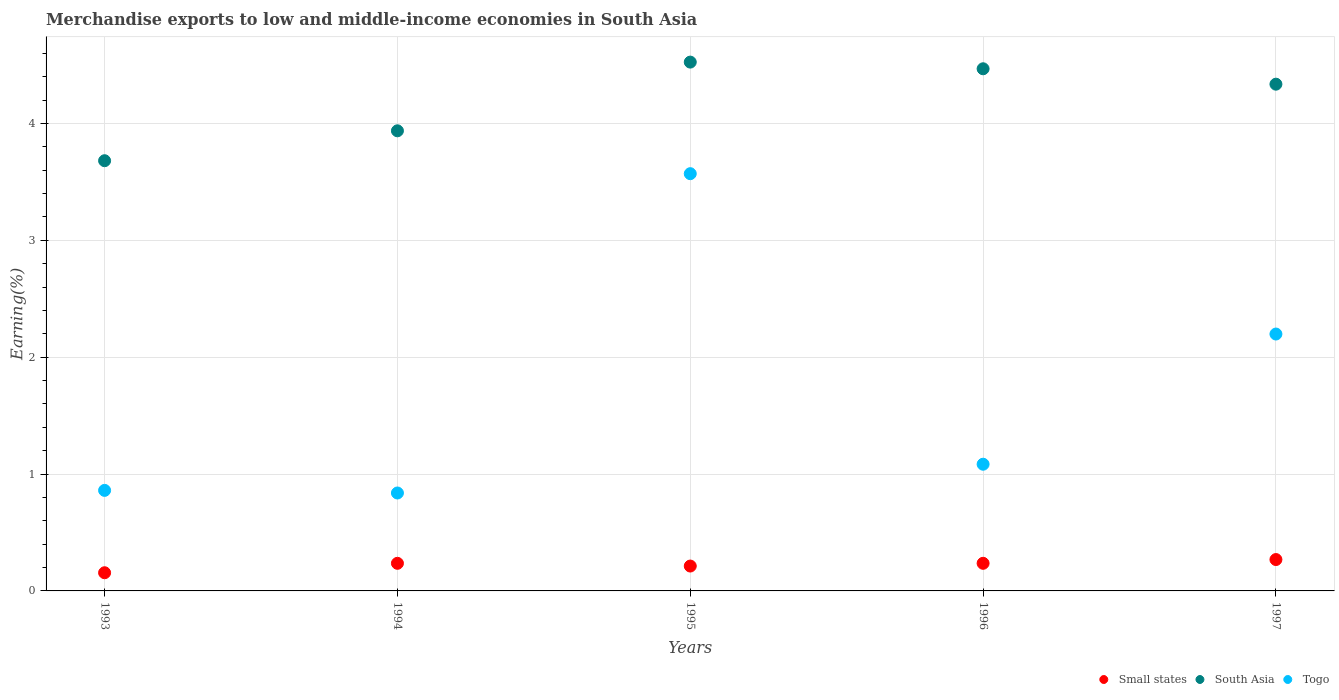Is the number of dotlines equal to the number of legend labels?
Offer a terse response. Yes. What is the percentage of amount earned from merchandise exports in South Asia in 1997?
Your answer should be compact. 4.34. Across all years, what is the maximum percentage of amount earned from merchandise exports in Small states?
Provide a succinct answer. 0.27. Across all years, what is the minimum percentage of amount earned from merchandise exports in Togo?
Offer a very short reply. 0.84. In which year was the percentage of amount earned from merchandise exports in South Asia maximum?
Provide a succinct answer. 1995. What is the total percentage of amount earned from merchandise exports in South Asia in the graph?
Your answer should be compact. 20.95. What is the difference between the percentage of amount earned from merchandise exports in Togo in 1993 and that in 1997?
Make the answer very short. -1.34. What is the difference between the percentage of amount earned from merchandise exports in Small states in 1993 and the percentage of amount earned from merchandise exports in South Asia in 1997?
Give a very brief answer. -4.18. What is the average percentage of amount earned from merchandise exports in South Asia per year?
Your answer should be compact. 4.19. In the year 1997, what is the difference between the percentage of amount earned from merchandise exports in Small states and percentage of amount earned from merchandise exports in South Asia?
Your answer should be very brief. -4.07. What is the ratio of the percentage of amount earned from merchandise exports in Togo in 1994 to that in 1995?
Offer a very short reply. 0.23. Is the percentage of amount earned from merchandise exports in Small states in 1995 less than that in 1997?
Your response must be concise. Yes. What is the difference between the highest and the second highest percentage of amount earned from merchandise exports in Togo?
Offer a very short reply. 1.37. What is the difference between the highest and the lowest percentage of amount earned from merchandise exports in Small states?
Your answer should be very brief. 0.11. Is the sum of the percentage of amount earned from merchandise exports in Togo in 1994 and 1997 greater than the maximum percentage of amount earned from merchandise exports in Small states across all years?
Provide a short and direct response. Yes. Is the percentage of amount earned from merchandise exports in Small states strictly less than the percentage of amount earned from merchandise exports in South Asia over the years?
Offer a very short reply. Yes. How many dotlines are there?
Offer a very short reply. 3. How many years are there in the graph?
Your response must be concise. 5. Are the values on the major ticks of Y-axis written in scientific E-notation?
Provide a succinct answer. No. Does the graph contain any zero values?
Ensure brevity in your answer.  No. Does the graph contain grids?
Provide a short and direct response. Yes. Where does the legend appear in the graph?
Provide a short and direct response. Bottom right. How are the legend labels stacked?
Your answer should be compact. Horizontal. What is the title of the graph?
Provide a short and direct response. Merchandise exports to low and middle-income economies in South Asia. Does "Sub-Saharan Africa (all income levels)" appear as one of the legend labels in the graph?
Provide a short and direct response. No. What is the label or title of the Y-axis?
Ensure brevity in your answer.  Earning(%). What is the Earning(%) of Small states in 1993?
Offer a terse response. 0.16. What is the Earning(%) of South Asia in 1993?
Provide a succinct answer. 3.68. What is the Earning(%) in Togo in 1993?
Provide a succinct answer. 0.86. What is the Earning(%) of Small states in 1994?
Provide a succinct answer. 0.24. What is the Earning(%) of South Asia in 1994?
Keep it short and to the point. 3.94. What is the Earning(%) of Togo in 1994?
Give a very brief answer. 0.84. What is the Earning(%) in Small states in 1995?
Your answer should be very brief. 0.21. What is the Earning(%) of South Asia in 1995?
Your response must be concise. 4.52. What is the Earning(%) of Togo in 1995?
Offer a very short reply. 3.57. What is the Earning(%) of Small states in 1996?
Your answer should be compact. 0.24. What is the Earning(%) in South Asia in 1996?
Offer a very short reply. 4.47. What is the Earning(%) of Togo in 1996?
Provide a succinct answer. 1.08. What is the Earning(%) in Small states in 1997?
Provide a short and direct response. 0.27. What is the Earning(%) of South Asia in 1997?
Ensure brevity in your answer.  4.34. What is the Earning(%) of Togo in 1997?
Ensure brevity in your answer.  2.2. Across all years, what is the maximum Earning(%) of Small states?
Provide a succinct answer. 0.27. Across all years, what is the maximum Earning(%) of South Asia?
Offer a terse response. 4.52. Across all years, what is the maximum Earning(%) of Togo?
Your answer should be very brief. 3.57. Across all years, what is the minimum Earning(%) of Small states?
Your response must be concise. 0.16. Across all years, what is the minimum Earning(%) of South Asia?
Offer a very short reply. 3.68. Across all years, what is the minimum Earning(%) of Togo?
Provide a short and direct response. 0.84. What is the total Earning(%) of Small states in the graph?
Make the answer very short. 1.11. What is the total Earning(%) of South Asia in the graph?
Your answer should be compact. 20.95. What is the total Earning(%) of Togo in the graph?
Give a very brief answer. 8.55. What is the difference between the Earning(%) of Small states in 1993 and that in 1994?
Your answer should be very brief. -0.08. What is the difference between the Earning(%) in South Asia in 1993 and that in 1994?
Keep it short and to the point. -0.26. What is the difference between the Earning(%) of Togo in 1993 and that in 1994?
Your response must be concise. 0.02. What is the difference between the Earning(%) of Small states in 1993 and that in 1995?
Your answer should be compact. -0.06. What is the difference between the Earning(%) in South Asia in 1993 and that in 1995?
Provide a succinct answer. -0.84. What is the difference between the Earning(%) in Togo in 1993 and that in 1995?
Give a very brief answer. -2.71. What is the difference between the Earning(%) of Small states in 1993 and that in 1996?
Provide a succinct answer. -0.08. What is the difference between the Earning(%) in South Asia in 1993 and that in 1996?
Your answer should be compact. -0.79. What is the difference between the Earning(%) in Togo in 1993 and that in 1996?
Give a very brief answer. -0.22. What is the difference between the Earning(%) of Small states in 1993 and that in 1997?
Provide a succinct answer. -0.11. What is the difference between the Earning(%) of South Asia in 1993 and that in 1997?
Make the answer very short. -0.65. What is the difference between the Earning(%) in Togo in 1993 and that in 1997?
Ensure brevity in your answer.  -1.34. What is the difference between the Earning(%) of Small states in 1994 and that in 1995?
Your answer should be very brief. 0.02. What is the difference between the Earning(%) of South Asia in 1994 and that in 1995?
Ensure brevity in your answer.  -0.59. What is the difference between the Earning(%) in Togo in 1994 and that in 1995?
Make the answer very short. -2.73. What is the difference between the Earning(%) of South Asia in 1994 and that in 1996?
Offer a very short reply. -0.53. What is the difference between the Earning(%) in Togo in 1994 and that in 1996?
Your answer should be compact. -0.25. What is the difference between the Earning(%) in Small states in 1994 and that in 1997?
Ensure brevity in your answer.  -0.03. What is the difference between the Earning(%) of South Asia in 1994 and that in 1997?
Your answer should be very brief. -0.4. What is the difference between the Earning(%) of Togo in 1994 and that in 1997?
Make the answer very short. -1.36. What is the difference between the Earning(%) of Small states in 1995 and that in 1996?
Offer a terse response. -0.02. What is the difference between the Earning(%) in South Asia in 1995 and that in 1996?
Your answer should be compact. 0.06. What is the difference between the Earning(%) of Togo in 1995 and that in 1996?
Give a very brief answer. 2.49. What is the difference between the Earning(%) in Small states in 1995 and that in 1997?
Give a very brief answer. -0.06. What is the difference between the Earning(%) of South Asia in 1995 and that in 1997?
Your response must be concise. 0.19. What is the difference between the Earning(%) of Togo in 1995 and that in 1997?
Your response must be concise. 1.37. What is the difference between the Earning(%) in Small states in 1996 and that in 1997?
Provide a short and direct response. -0.03. What is the difference between the Earning(%) in South Asia in 1996 and that in 1997?
Give a very brief answer. 0.13. What is the difference between the Earning(%) of Togo in 1996 and that in 1997?
Offer a very short reply. -1.11. What is the difference between the Earning(%) of Small states in 1993 and the Earning(%) of South Asia in 1994?
Ensure brevity in your answer.  -3.78. What is the difference between the Earning(%) in Small states in 1993 and the Earning(%) in Togo in 1994?
Your answer should be compact. -0.68. What is the difference between the Earning(%) of South Asia in 1993 and the Earning(%) of Togo in 1994?
Ensure brevity in your answer.  2.84. What is the difference between the Earning(%) in Small states in 1993 and the Earning(%) in South Asia in 1995?
Offer a terse response. -4.37. What is the difference between the Earning(%) of Small states in 1993 and the Earning(%) of Togo in 1995?
Make the answer very short. -3.41. What is the difference between the Earning(%) of South Asia in 1993 and the Earning(%) of Togo in 1995?
Give a very brief answer. 0.11. What is the difference between the Earning(%) of Small states in 1993 and the Earning(%) of South Asia in 1996?
Your answer should be compact. -4.31. What is the difference between the Earning(%) of Small states in 1993 and the Earning(%) of Togo in 1996?
Offer a very short reply. -0.93. What is the difference between the Earning(%) in South Asia in 1993 and the Earning(%) in Togo in 1996?
Ensure brevity in your answer.  2.6. What is the difference between the Earning(%) of Small states in 1993 and the Earning(%) of South Asia in 1997?
Make the answer very short. -4.18. What is the difference between the Earning(%) of Small states in 1993 and the Earning(%) of Togo in 1997?
Your response must be concise. -2.04. What is the difference between the Earning(%) in South Asia in 1993 and the Earning(%) in Togo in 1997?
Your answer should be compact. 1.48. What is the difference between the Earning(%) in Small states in 1994 and the Earning(%) in South Asia in 1995?
Offer a very short reply. -4.29. What is the difference between the Earning(%) in Small states in 1994 and the Earning(%) in Togo in 1995?
Your answer should be compact. -3.33. What is the difference between the Earning(%) in South Asia in 1994 and the Earning(%) in Togo in 1995?
Offer a very short reply. 0.37. What is the difference between the Earning(%) of Small states in 1994 and the Earning(%) of South Asia in 1996?
Offer a terse response. -4.23. What is the difference between the Earning(%) in Small states in 1994 and the Earning(%) in Togo in 1996?
Your answer should be compact. -0.85. What is the difference between the Earning(%) of South Asia in 1994 and the Earning(%) of Togo in 1996?
Your answer should be compact. 2.85. What is the difference between the Earning(%) of Small states in 1994 and the Earning(%) of South Asia in 1997?
Make the answer very short. -4.1. What is the difference between the Earning(%) in Small states in 1994 and the Earning(%) in Togo in 1997?
Give a very brief answer. -1.96. What is the difference between the Earning(%) in South Asia in 1994 and the Earning(%) in Togo in 1997?
Keep it short and to the point. 1.74. What is the difference between the Earning(%) of Small states in 1995 and the Earning(%) of South Asia in 1996?
Make the answer very short. -4.26. What is the difference between the Earning(%) of Small states in 1995 and the Earning(%) of Togo in 1996?
Give a very brief answer. -0.87. What is the difference between the Earning(%) in South Asia in 1995 and the Earning(%) in Togo in 1996?
Keep it short and to the point. 3.44. What is the difference between the Earning(%) in Small states in 1995 and the Earning(%) in South Asia in 1997?
Ensure brevity in your answer.  -4.12. What is the difference between the Earning(%) in Small states in 1995 and the Earning(%) in Togo in 1997?
Offer a terse response. -1.99. What is the difference between the Earning(%) in South Asia in 1995 and the Earning(%) in Togo in 1997?
Offer a very short reply. 2.33. What is the difference between the Earning(%) of Small states in 1996 and the Earning(%) of South Asia in 1997?
Provide a succinct answer. -4.1. What is the difference between the Earning(%) of Small states in 1996 and the Earning(%) of Togo in 1997?
Keep it short and to the point. -1.96. What is the difference between the Earning(%) in South Asia in 1996 and the Earning(%) in Togo in 1997?
Offer a very short reply. 2.27. What is the average Earning(%) of Small states per year?
Your response must be concise. 0.22. What is the average Earning(%) of South Asia per year?
Keep it short and to the point. 4.19. What is the average Earning(%) of Togo per year?
Make the answer very short. 1.71. In the year 1993, what is the difference between the Earning(%) of Small states and Earning(%) of South Asia?
Provide a succinct answer. -3.53. In the year 1993, what is the difference between the Earning(%) of Small states and Earning(%) of Togo?
Give a very brief answer. -0.7. In the year 1993, what is the difference between the Earning(%) of South Asia and Earning(%) of Togo?
Make the answer very short. 2.82. In the year 1994, what is the difference between the Earning(%) in Small states and Earning(%) in South Asia?
Your answer should be very brief. -3.7. In the year 1994, what is the difference between the Earning(%) in Small states and Earning(%) in Togo?
Provide a short and direct response. -0.6. In the year 1994, what is the difference between the Earning(%) in South Asia and Earning(%) in Togo?
Provide a short and direct response. 3.1. In the year 1995, what is the difference between the Earning(%) of Small states and Earning(%) of South Asia?
Keep it short and to the point. -4.31. In the year 1995, what is the difference between the Earning(%) in Small states and Earning(%) in Togo?
Provide a short and direct response. -3.36. In the year 1995, what is the difference between the Earning(%) in South Asia and Earning(%) in Togo?
Offer a terse response. 0.95. In the year 1996, what is the difference between the Earning(%) in Small states and Earning(%) in South Asia?
Your answer should be compact. -4.23. In the year 1996, what is the difference between the Earning(%) of Small states and Earning(%) of Togo?
Provide a short and direct response. -0.85. In the year 1996, what is the difference between the Earning(%) in South Asia and Earning(%) in Togo?
Provide a succinct answer. 3.38. In the year 1997, what is the difference between the Earning(%) of Small states and Earning(%) of South Asia?
Provide a succinct answer. -4.07. In the year 1997, what is the difference between the Earning(%) in Small states and Earning(%) in Togo?
Ensure brevity in your answer.  -1.93. In the year 1997, what is the difference between the Earning(%) in South Asia and Earning(%) in Togo?
Provide a short and direct response. 2.14. What is the ratio of the Earning(%) in Small states in 1993 to that in 1994?
Offer a very short reply. 0.66. What is the ratio of the Earning(%) of South Asia in 1993 to that in 1994?
Give a very brief answer. 0.94. What is the ratio of the Earning(%) of Togo in 1993 to that in 1994?
Provide a short and direct response. 1.03. What is the ratio of the Earning(%) in Small states in 1993 to that in 1995?
Offer a very short reply. 0.73. What is the ratio of the Earning(%) of South Asia in 1993 to that in 1995?
Make the answer very short. 0.81. What is the ratio of the Earning(%) in Togo in 1993 to that in 1995?
Offer a terse response. 0.24. What is the ratio of the Earning(%) in Small states in 1993 to that in 1996?
Offer a very short reply. 0.66. What is the ratio of the Earning(%) in South Asia in 1993 to that in 1996?
Make the answer very short. 0.82. What is the ratio of the Earning(%) in Togo in 1993 to that in 1996?
Keep it short and to the point. 0.79. What is the ratio of the Earning(%) in Small states in 1993 to that in 1997?
Your answer should be very brief. 0.58. What is the ratio of the Earning(%) in South Asia in 1993 to that in 1997?
Provide a short and direct response. 0.85. What is the ratio of the Earning(%) in Togo in 1993 to that in 1997?
Give a very brief answer. 0.39. What is the ratio of the Earning(%) of Small states in 1994 to that in 1995?
Make the answer very short. 1.11. What is the ratio of the Earning(%) in South Asia in 1994 to that in 1995?
Your answer should be compact. 0.87. What is the ratio of the Earning(%) of Togo in 1994 to that in 1995?
Your response must be concise. 0.23. What is the ratio of the Earning(%) in Small states in 1994 to that in 1996?
Ensure brevity in your answer.  1. What is the ratio of the Earning(%) of South Asia in 1994 to that in 1996?
Make the answer very short. 0.88. What is the ratio of the Earning(%) in Togo in 1994 to that in 1996?
Your answer should be compact. 0.77. What is the ratio of the Earning(%) of Small states in 1994 to that in 1997?
Ensure brevity in your answer.  0.88. What is the ratio of the Earning(%) of South Asia in 1994 to that in 1997?
Provide a short and direct response. 0.91. What is the ratio of the Earning(%) in Togo in 1994 to that in 1997?
Make the answer very short. 0.38. What is the ratio of the Earning(%) in Small states in 1995 to that in 1996?
Give a very brief answer. 0.9. What is the ratio of the Earning(%) of South Asia in 1995 to that in 1996?
Provide a succinct answer. 1.01. What is the ratio of the Earning(%) in Togo in 1995 to that in 1996?
Provide a short and direct response. 3.29. What is the ratio of the Earning(%) of Small states in 1995 to that in 1997?
Provide a succinct answer. 0.79. What is the ratio of the Earning(%) in South Asia in 1995 to that in 1997?
Your response must be concise. 1.04. What is the ratio of the Earning(%) in Togo in 1995 to that in 1997?
Give a very brief answer. 1.62. What is the ratio of the Earning(%) of Small states in 1996 to that in 1997?
Provide a succinct answer. 0.88. What is the ratio of the Earning(%) in South Asia in 1996 to that in 1997?
Make the answer very short. 1.03. What is the ratio of the Earning(%) in Togo in 1996 to that in 1997?
Ensure brevity in your answer.  0.49. What is the difference between the highest and the second highest Earning(%) in Small states?
Make the answer very short. 0.03. What is the difference between the highest and the second highest Earning(%) of South Asia?
Offer a very short reply. 0.06. What is the difference between the highest and the second highest Earning(%) in Togo?
Your response must be concise. 1.37. What is the difference between the highest and the lowest Earning(%) of Small states?
Your answer should be compact. 0.11. What is the difference between the highest and the lowest Earning(%) of South Asia?
Give a very brief answer. 0.84. What is the difference between the highest and the lowest Earning(%) in Togo?
Keep it short and to the point. 2.73. 